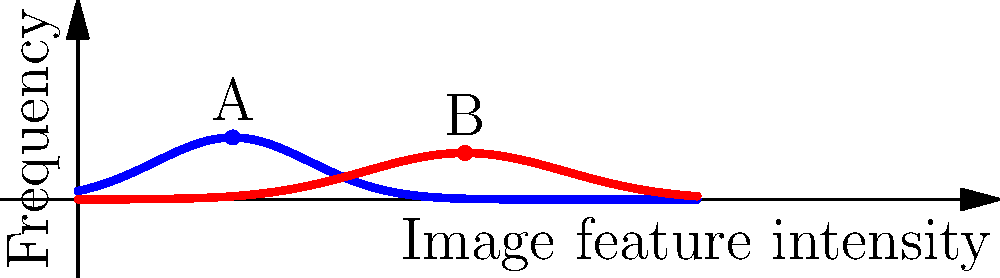In a machine learning model for classifying medical images to detect cancer types, the graph shows the distribution of a particular image feature intensity for benign and malignant tumors. Based on this information, which of the following statements is most accurate for improving the model's performance in distinguishing between benign and malignant tumors? To answer this question, we need to analyze the graph and understand its implications for machine learning classification:

1. The graph shows two distributions: blue for benign tumors and red for malignant tumors.

2. The x-axis represents the image feature intensity, while the y-axis represents the frequency of occurrence.

3. We can observe that:
   a. The benign tumor distribution (blue) peaks at point A, around an intensity of 2.
   b. The malignant tumor distribution (red) peaks at point B, around an intensity of 5.

4. There is some overlap between the two distributions, but they are largely separated.

5. For improving the model's performance:
   a. The feature shown is informative, as it helps distinguish between benign and malignant tumors.
   b. However, there is still some overlap, which could lead to misclassifications.
   c. To improve performance, we should consider:
      i. Using this feature in combination with others to reduce misclassifications.
      ii. Applying appropriate thresholds or decision boundaries.
      iii. Potentially using more advanced techniques like ensemble methods or deep learning to capture complex patterns.

6. The most accurate statement would emphasize the usefulness of this feature while acknowledging the need for additional information or techniques to improve classification accuracy.
Answer: Utilize this feature in combination with others and consider advanced techniques to improve classification accuracy. 